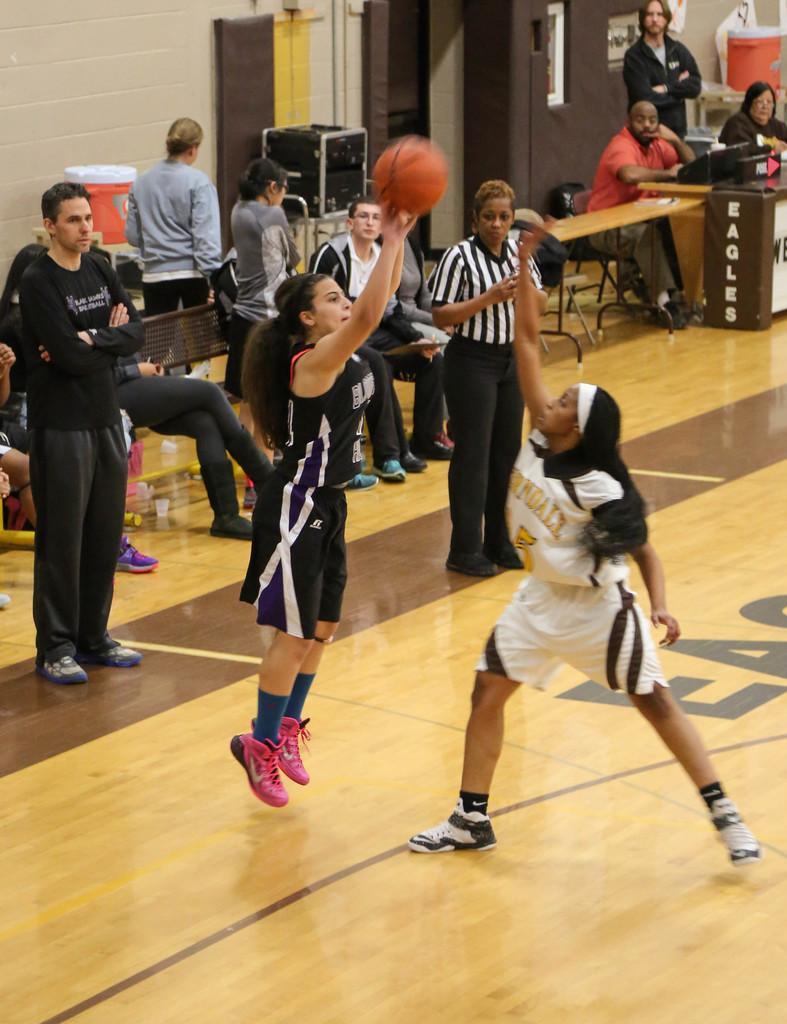Please provide a concise description of this image. In the center of the image there are women playing on the ground. In the background we can see speakers, table, chairs, door, window and wall. 